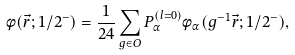<formula> <loc_0><loc_0><loc_500><loc_500>\phi ( \vec { r } ; 1 / 2 ^ { - } ) = \frac { 1 } { 2 4 } \sum _ { g \in O } P ^ { ( l = 0 ) } _ { \alpha } \phi _ { \alpha } ( g ^ { - 1 } \vec { r } ; 1 / 2 ^ { - } ) ,</formula> 